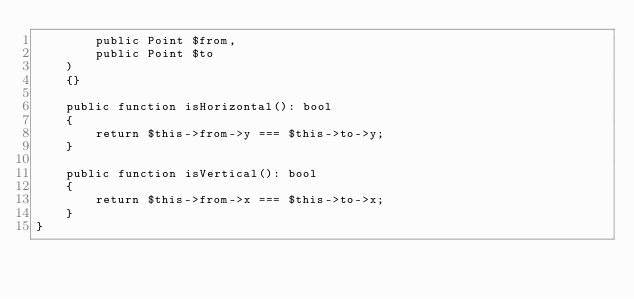<code> <loc_0><loc_0><loc_500><loc_500><_PHP_>        public Point $from,
        public Point $to
    )
    {}

    public function isHorizontal(): bool
    {
        return $this->from->y === $this->to->y;
    }

    public function isVertical(): bool
    {
        return $this->from->x === $this->to->x;
    }
}
</code> 